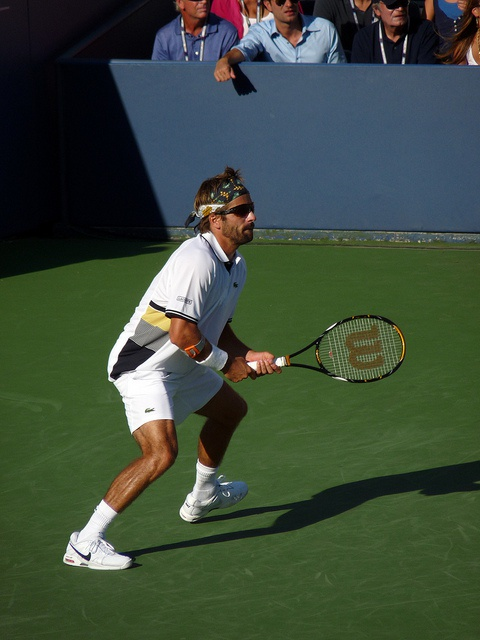Describe the objects in this image and their specific colors. I can see people in black, white, blue, and gray tones, tennis racket in black and darkgreen tones, people in black, darkgray, and brown tones, people in black, brown, maroon, and gray tones, and people in black, gray, blue, and navy tones in this image. 